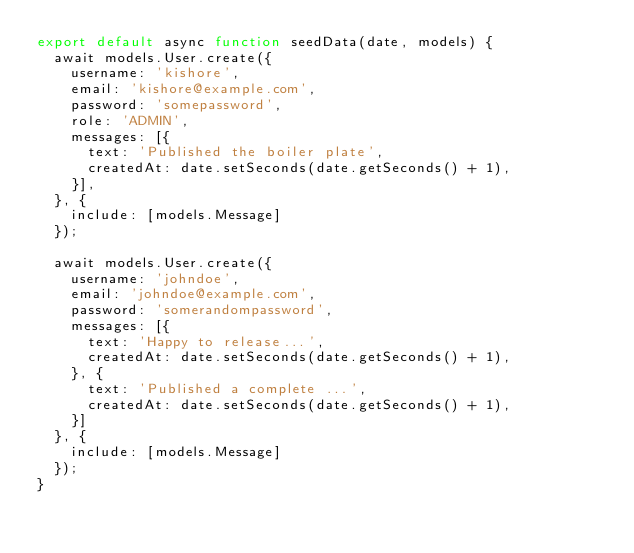<code> <loc_0><loc_0><loc_500><loc_500><_JavaScript_>export default async function seedData(date, models) {
  await models.User.create({
    username: 'kishore',
    email: 'kishore@example.com',
    password: 'somepassword',
    role: 'ADMIN',
    messages: [{
      text: 'Published the boiler plate',
      createdAt: date.setSeconds(date.getSeconds() + 1),
    }],
  }, {
    include: [models.Message]
  });

  await models.User.create({
    username: 'johndoe',
    email: 'johndoe@example.com',
    password: 'somerandompassword',
    messages: [{
      text: 'Happy to release...',
      createdAt: date.setSeconds(date.getSeconds() + 1),
    }, {
      text: 'Published a complete ...',
      createdAt: date.setSeconds(date.getSeconds() + 1),
    }]
  }, {
    include: [models.Message]
  });
}</code> 